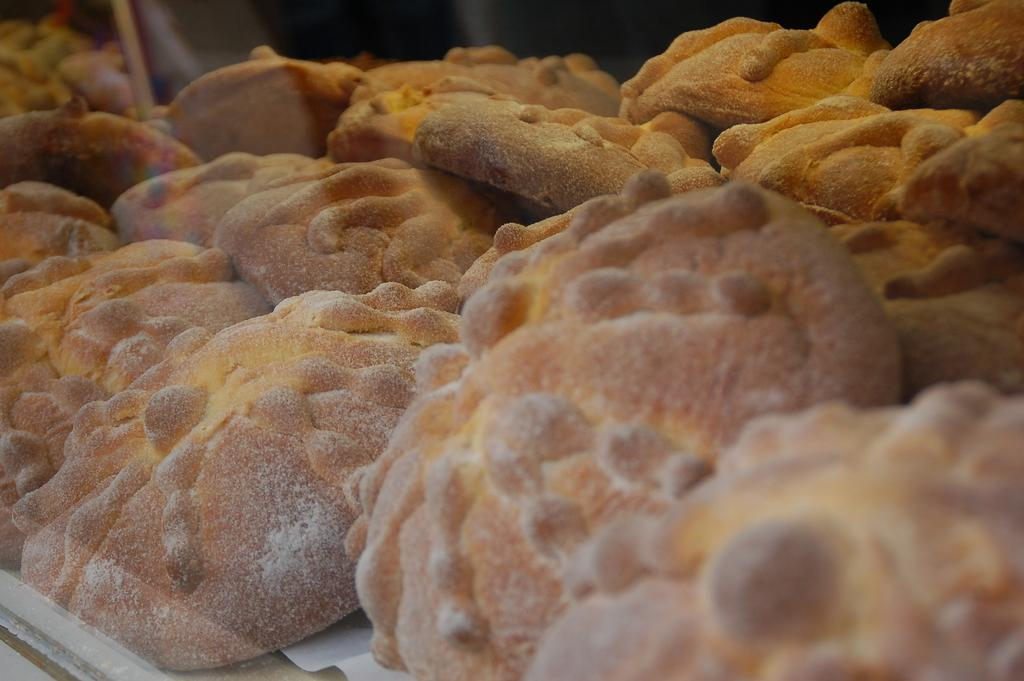What type of food can be seen in the image? There is a baked food item in the image. What type of hat is the grandfather wearing in the image? There is no hat or grandfather present in the image; it only features a baked food item. 